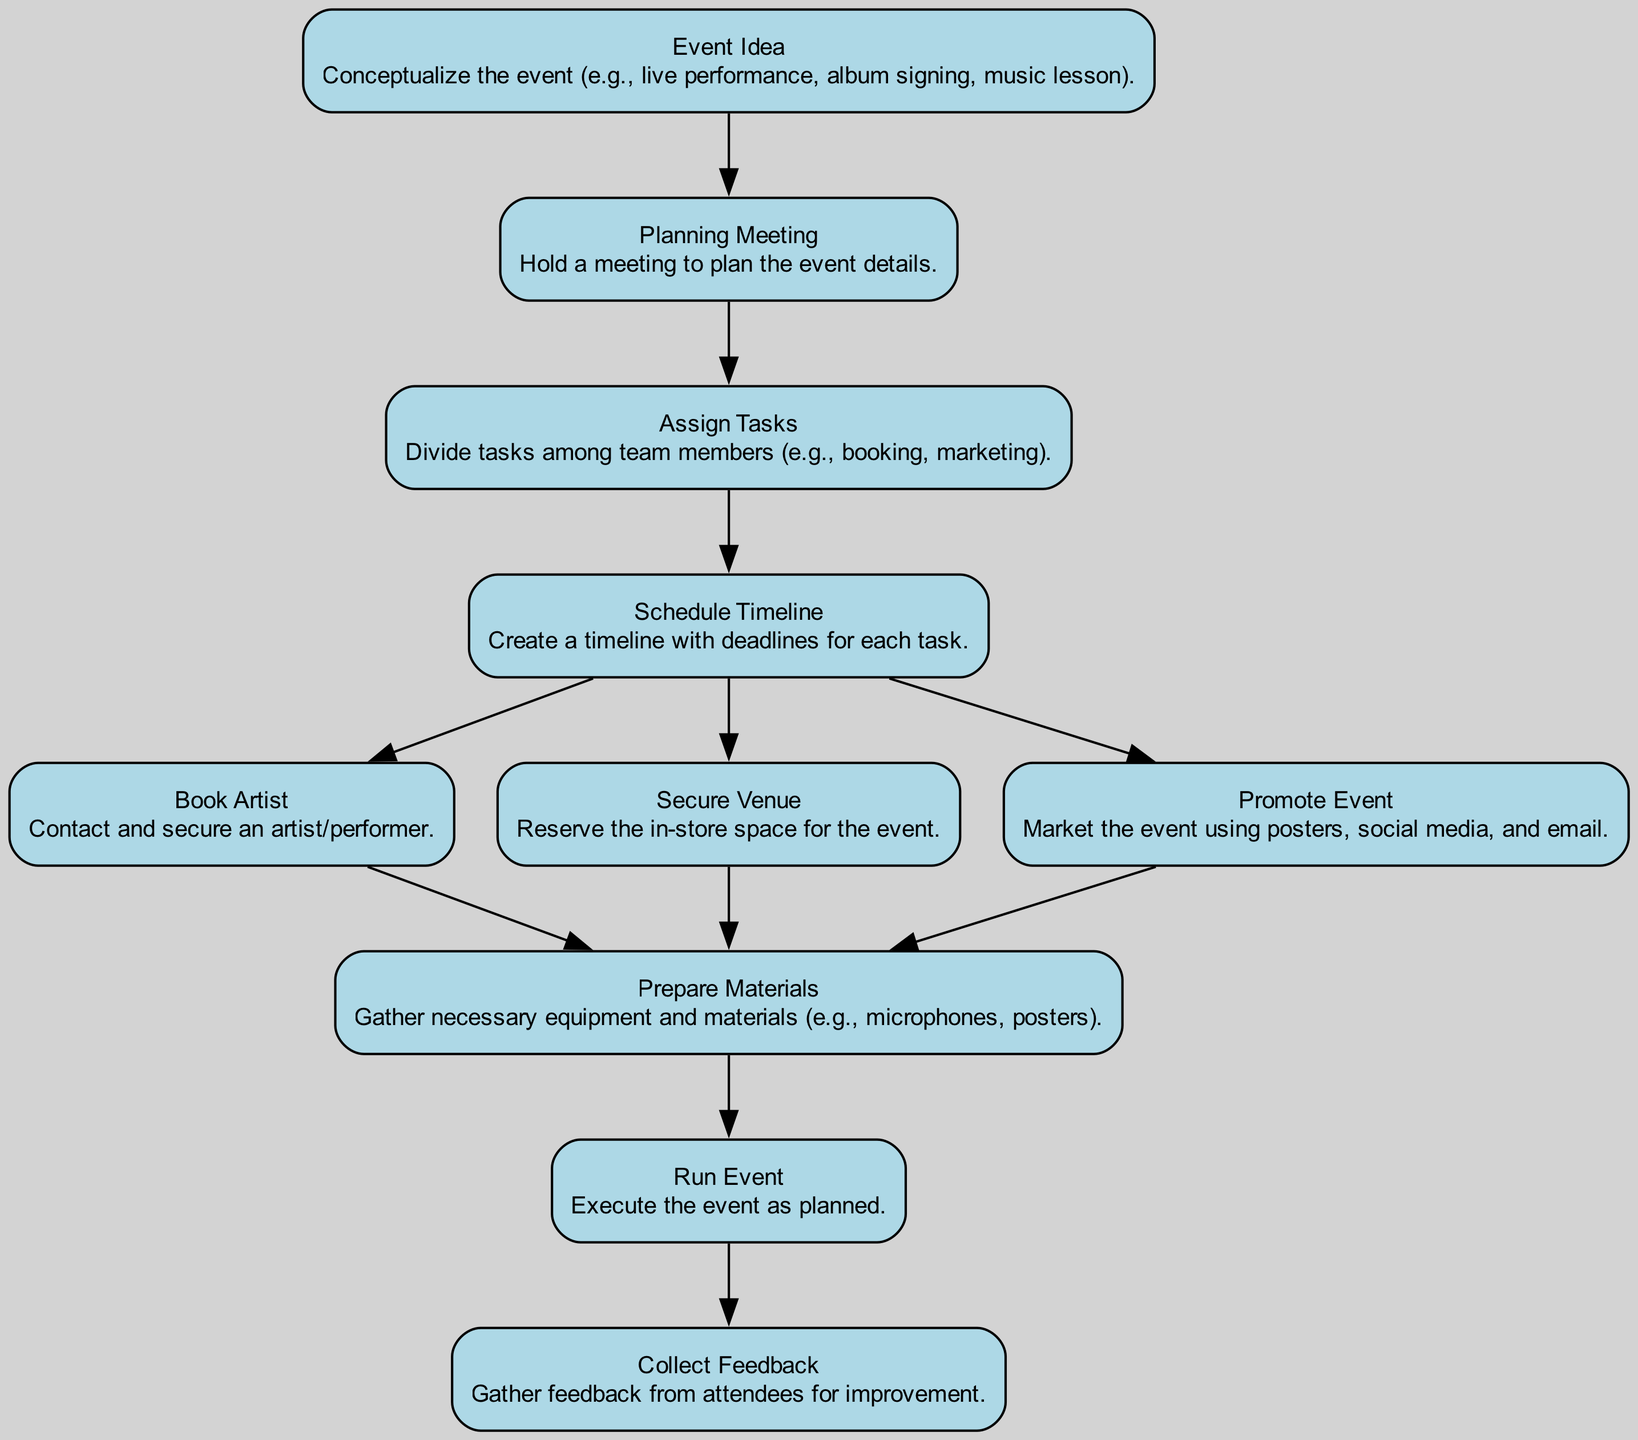What is the first step in organizing an event? The first node in the flowchart is "Event Idea," which indicates the initial step of conceptualizing the event.
Answer: Event Idea How many nodes are in the diagram? The diagram contains ten nodes, representing different steps in the in-store event planning process.
Answer: 10 What task is assigned after the planning meeting? After the "Planning Meeting," the next task is "Assign Tasks," as indicated by the edge connecting these two nodes.
Answer: Assign Tasks What is the last step before collecting feedback? The last step before "Collect Feedback" is "Run Event," which is where the event is executed as planned.
Answer: Run Event Which tasks occur after scheduling the timeline? After "Schedule Timeline," the tasks that follow are "Book Artist," "Secure Venue," and "Promote Event," as three edges lead from "Schedule Timeline" to these nodes.
Answer: Book Artist, Secure Venue, Promote Event What happens immediately after collecting feedback? The flowchart does not indicate any steps after "Collect Feedback," which is the final node, meaning there are no subsequent actions described.
Answer: None How many tasks need to be prepared after securing the venue? After "Secure Venue," the task to be completed is "Prepare Materials," as indicated by the edge leading to that node.
Answer: 1 What do you need to do before promoting the event? Before promoting the event, tasks "Book Artist" and "Secure Venue" must be completed to gather sufficient information and resources.
Answer: Book Artist, Secure Venue What is the main purpose of the planning meeting? The "Planning Meeting" node is focused on holding discussions to plan the event's details effectively.
Answer: Plan event details 